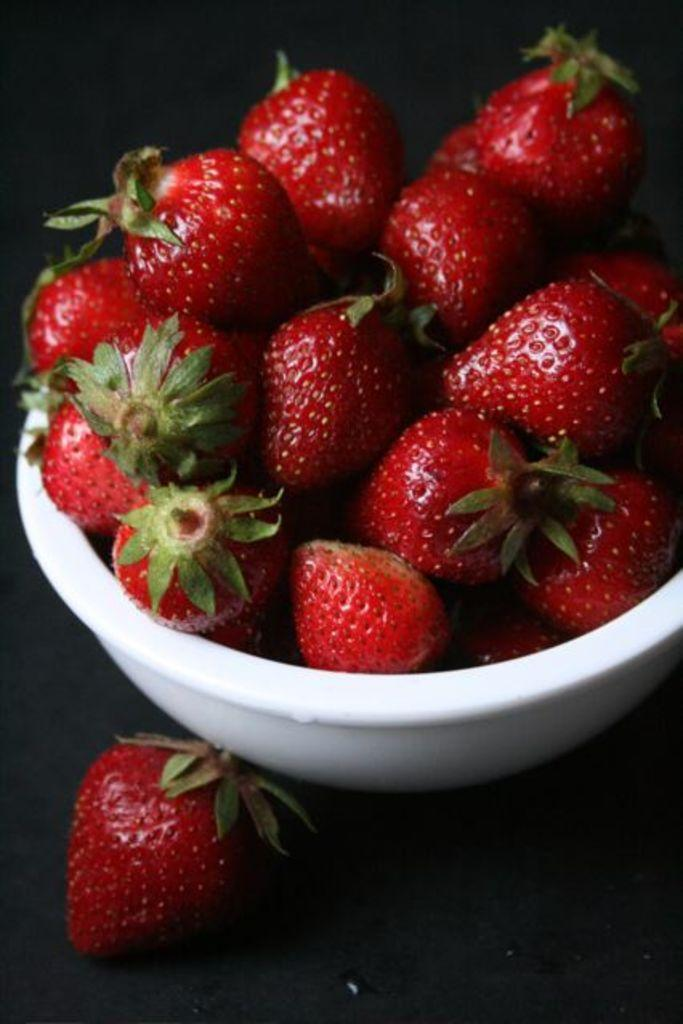What type of fruit is visible in the image? There are red color strawberries in the image. In what type of container are the strawberries placed? The strawberries are in a white bowl. What color is the background of the image? The background of the image is black. What type of health record can be seen in the image? There is no health record present in the image; it features strawberries in a white bowl with a black background. 